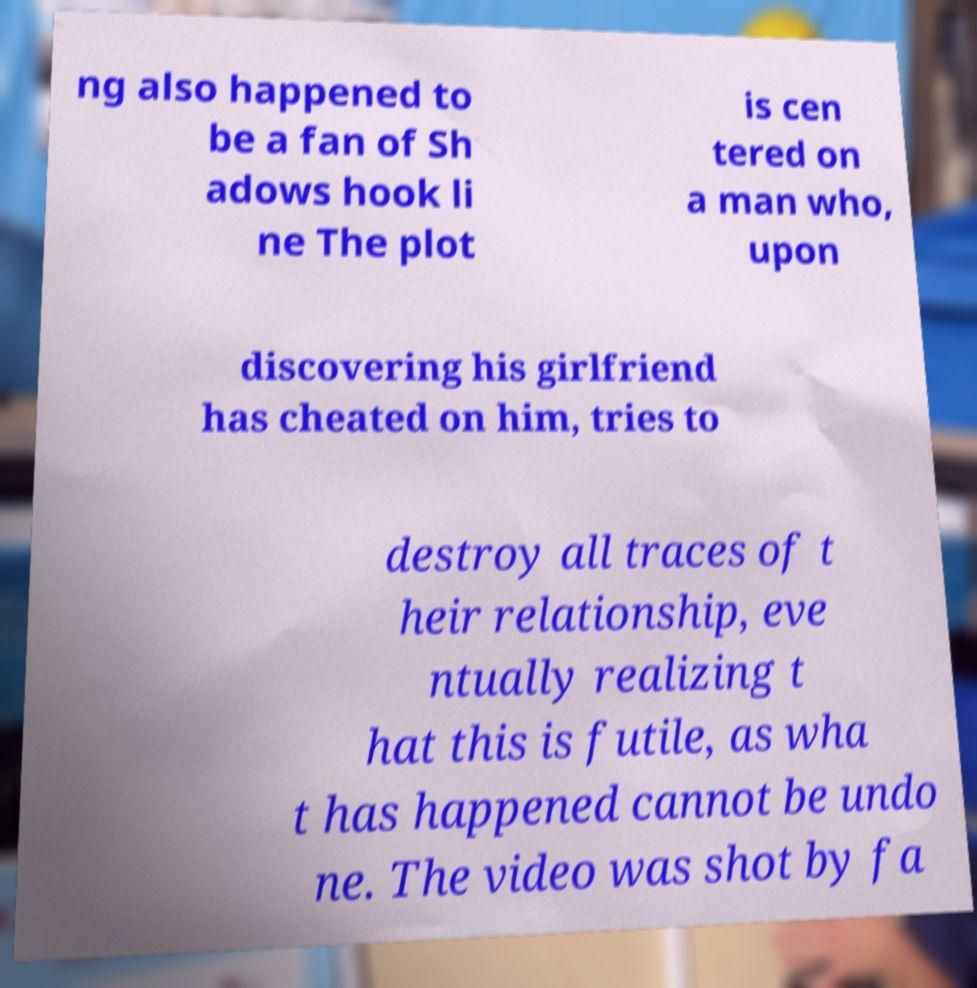What messages or text are displayed in this image? I need them in a readable, typed format. ng also happened to be a fan of Sh adows hook li ne The plot is cen tered on a man who, upon discovering his girlfriend has cheated on him, tries to destroy all traces of t heir relationship, eve ntually realizing t hat this is futile, as wha t has happened cannot be undo ne. The video was shot by fa 